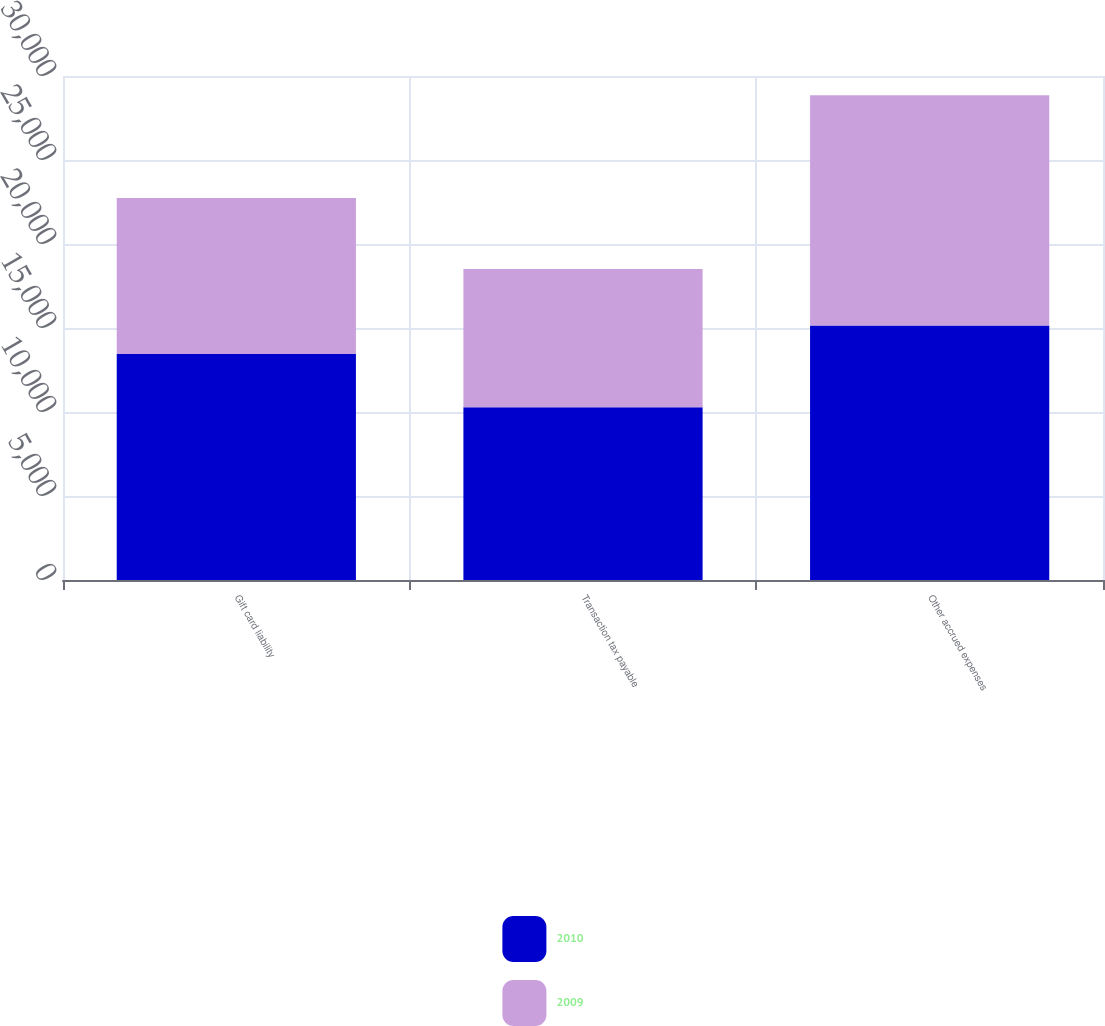Convert chart. <chart><loc_0><loc_0><loc_500><loc_500><stacked_bar_chart><ecel><fcel>Gift card liability<fcel>Transaction tax payable<fcel>Other accrued expenses<nl><fcel>2010<fcel>13456<fcel>10280<fcel>15156<nl><fcel>2009<fcel>9281<fcel>8237<fcel>13698<nl></chart> 